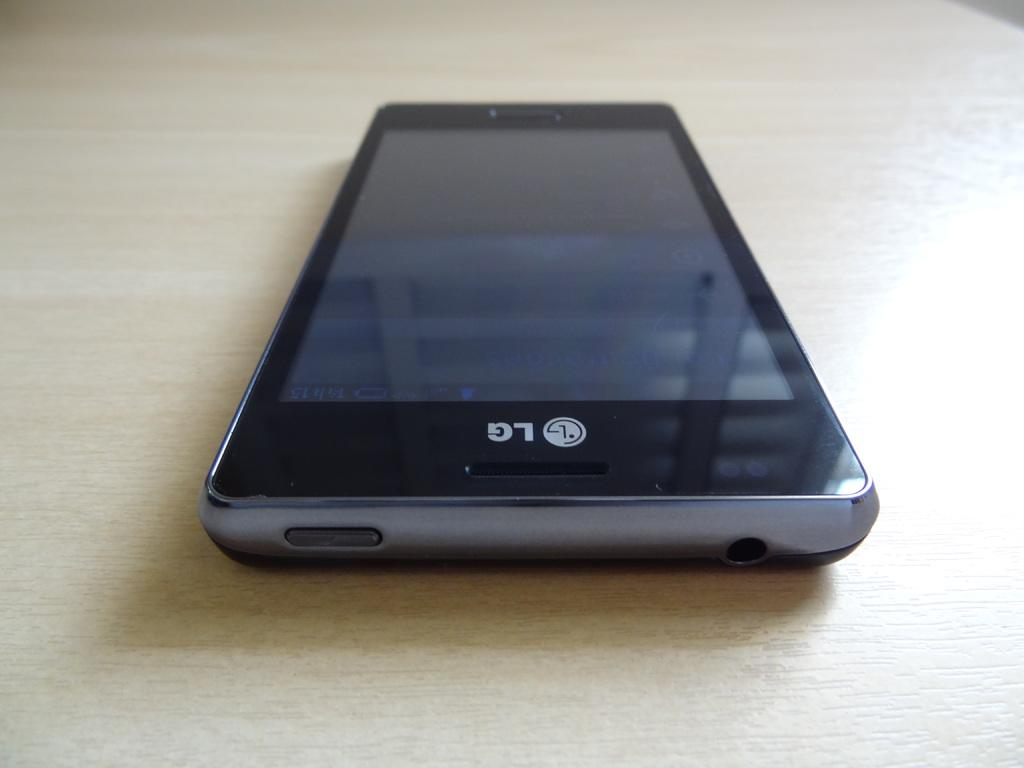<image>
Summarize the visual content of the image. An LG phone is sitting on a table. 